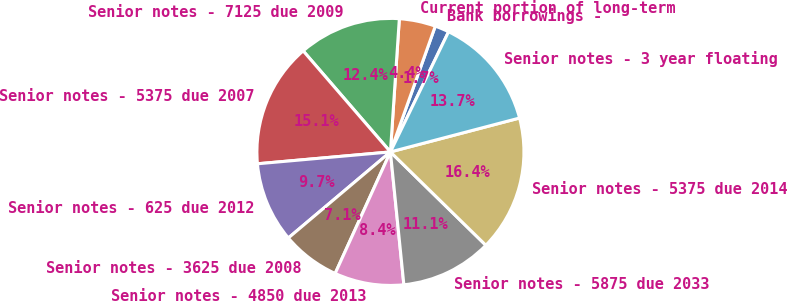Convert chart to OTSL. <chart><loc_0><loc_0><loc_500><loc_500><pie_chart><fcel>Bank borrowings -<fcel>Current portion of long-term<fcel>Senior notes - 7125 due 2009<fcel>Senior notes - 5375 due 2007<fcel>Senior notes - 625 due 2012<fcel>Senior notes - 3625 due 2008<fcel>Senior notes - 4850 due 2013<fcel>Senior notes - 5875 due 2033<fcel>Senior notes - 5375 due 2014<fcel>Senior notes - 3 year floating<nl><fcel>1.72%<fcel>4.39%<fcel>12.4%<fcel>15.08%<fcel>9.73%<fcel>7.06%<fcel>8.4%<fcel>11.07%<fcel>16.41%<fcel>13.74%<nl></chart> 